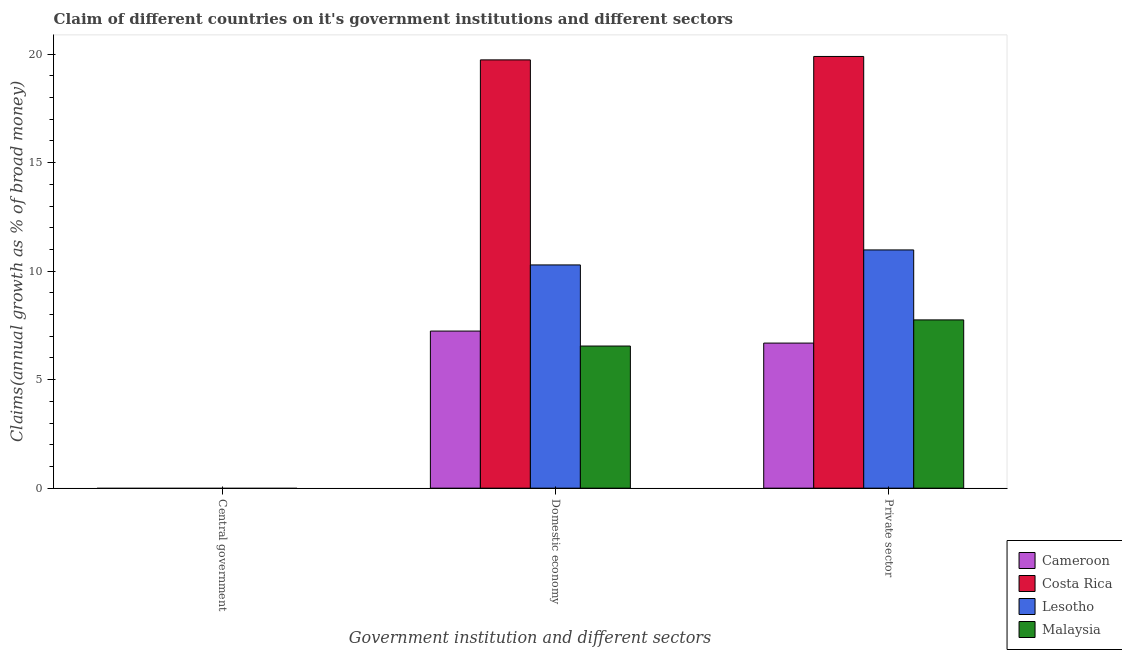Are the number of bars per tick equal to the number of legend labels?
Your response must be concise. No. Are the number of bars on each tick of the X-axis equal?
Offer a terse response. No. How many bars are there on the 3rd tick from the left?
Keep it short and to the point. 4. What is the label of the 2nd group of bars from the left?
Give a very brief answer. Domestic economy. What is the percentage of claim on the central government in Lesotho?
Offer a very short reply. 0. Across all countries, what is the maximum percentage of claim on the domestic economy?
Make the answer very short. 19.73. Across all countries, what is the minimum percentage of claim on the central government?
Ensure brevity in your answer.  0. What is the total percentage of claim on the domestic economy in the graph?
Your response must be concise. 43.81. What is the difference between the percentage of claim on the domestic economy in Lesotho and that in Costa Rica?
Your answer should be compact. -9.45. What is the difference between the percentage of claim on the central government in Cameroon and the percentage of claim on the private sector in Malaysia?
Offer a terse response. -7.75. What is the difference between the percentage of claim on the private sector and percentage of claim on the domestic economy in Cameroon?
Provide a short and direct response. -0.55. What is the ratio of the percentage of claim on the private sector in Costa Rica to that in Lesotho?
Provide a succinct answer. 1.81. What is the difference between the highest and the second highest percentage of claim on the private sector?
Provide a succinct answer. 8.91. What is the difference between the highest and the lowest percentage of claim on the private sector?
Provide a succinct answer. 13.21. In how many countries, is the percentage of claim on the domestic economy greater than the average percentage of claim on the domestic economy taken over all countries?
Keep it short and to the point. 1. Is it the case that in every country, the sum of the percentage of claim on the central government and percentage of claim on the domestic economy is greater than the percentage of claim on the private sector?
Provide a succinct answer. No. How many bars are there?
Your answer should be very brief. 8. What is the difference between two consecutive major ticks on the Y-axis?
Ensure brevity in your answer.  5. Where does the legend appear in the graph?
Offer a terse response. Bottom right. How are the legend labels stacked?
Make the answer very short. Vertical. What is the title of the graph?
Make the answer very short. Claim of different countries on it's government institutions and different sectors. Does "Sub-Saharan Africa (all income levels)" appear as one of the legend labels in the graph?
Provide a short and direct response. No. What is the label or title of the X-axis?
Provide a short and direct response. Government institution and different sectors. What is the label or title of the Y-axis?
Your response must be concise. Claims(annual growth as % of broad money). What is the Claims(annual growth as % of broad money) of Costa Rica in Central government?
Provide a short and direct response. 0. What is the Claims(annual growth as % of broad money) of Cameroon in Domestic economy?
Keep it short and to the point. 7.24. What is the Claims(annual growth as % of broad money) in Costa Rica in Domestic economy?
Offer a terse response. 19.73. What is the Claims(annual growth as % of broad money) of Lesotho in Domestic economy?
Provide a succinct answer. 10.29. What is the Claims(annual growth as % of broad money) in Malaysia in Domestic economy?
Ensure brevity in your answer.  6.55. What is the Claims(annual growth as % of broad money) of Cameroon in Private sector?
Offer a very short reply. 6.68. What is the Claims(annual growth as % of broad money) in Costa Rica in Private sector?
Your answer should be very brief. 19.89. What is the Claims(annual growth as % of broad money) in Lesotho in Private sector?
Offer a very short reply. 10.98. What is the Claims(annual growth as % of broad money) of Malaysia in Private sector?
Provide a short and direct response. 7.75. Across all Government institution and different sectors, what is the maximum Claims(annual growth as % of broad money) in Cameroon?
Your answer should be very brief. 7.24. Across all Government institution and different sectors, what is the maximum Claims(annual growth as % of broad money) of Costa Rica?
Ensure brevity in your answer.  19.89. Across all Government institution and different sectors, what is the maximum Claims(annual growth as % of broad money) of Lesotho?
Your answer should be very brief. 10.98. Across all Government institution and different sectors, what is the maximum Claims(annual growth as % of broad money) in Malaysia?
Your response must be concise. 7.75. Across all Government institution and different sectors, what is the minimum Claims(annual growth as % of broad money) of Lesotho?
Ensure brevity in your answer.  0. What is the total Claims(annual growth as % of broad money) of Cameroon in the graph?
Provide a short and direct response. 13.92. What is the total Claims(annual growth as % of broad money) of Costa Rica in the graph?
Make the answer very short. 39.62. What is the total Claims(annual growth as % of broad money) in Lesotho in the graph?
Ensure brevity in your answer.  21.26. What is the total Claims(annual growth as % of broad money) in Malaysia in the graph?
Offer a very short reply. 14.3. What is the difference between the Claims(annual growth as % of broad money) of Cameroon in Domestic economy and that in Private sector?
Offer a very short reply. 0.55. What is the difference between the Claims(annual growth as % of broad money) of Costa Rica in Domestic economy and that in Private sector?
Ensure brevity in your answer.  -0.16. What is the difference between the Claims(annual growth as % of broad money) in Lesotho in Domestic economy and that in Private sector?
Provide a succinct answer. -0.69. What is the difference between the Claims(annual growth as % of broad money) in Malaysia in Domestic economy and that in Private sector?
Your answer should be compact. -1.2. What is the difference between the Claims(annual growth as % of broad money) in Cameroon in Domestic economy and the Claims(annual growth as % of broad money) in Costa Rica in Private sector?
Ensure brevity in your answer.  -12.65. What is the difference between the Claims(annual growth as % of broad money) of Cameroon in Domestic economy and the Claims(annual growth as % of broad money) of Lesotho in Private sector?
Offer a very short reply. -3.74. What is the difference between the Claims(annual growth as % of broad money) in Cameroon in Domestic economy and the Claims(annual growth as % of broad money) in Malaysia in Private sector?
Make the answer very short. -0.51. What is the difference between the Claims(annual growth as % of broad money) of Costa Rica in Domestic economy and the Claims(annual growth as % of broad money) of Lesotho in Private sector?
Your response must be concise. 8.76. What is the difference between the Claims(annual growth as % of broad money) in Costa Rica in Domestic economy and the Claims(annual growth as % of broad money) in Malaysia in Private sector?
Your answer should be compact. 11.98. What is the difference between the Claims(annual growth as % of broad money) of Lesotho in Domestic economy and the Claims(annual growth as % of broad money) of Malaysia in Private sector?
Your answer should be compact. 2.53. What is the average Claims(annual growth as % of broad money) in Cameroon per Government institution and different sectors?
Offer a very short reply. 4.64. What is the average Claims(annual growth as % of broad money) of Costa Rica per Government institution and different sectors?
Offer a very short reply. 13.21. What is the average Claims(annual growth as % of broad money) in Lesotho per Government institution and different sectors?
Make the answer very short. 7.09. What is the average Claims(annual growth as % of broad money) of Malaysia per Government institution and different sectors?
Ensure brevity in your answer.  4.77. What is the difference between the Claims(annual growth as % of broad money) of Cameroon and Claims(annual growth as % of broad money) of Costa Rica in Domestic economy?
Provide a short and direct response. -12.5. What is the difference between the Claims(annual growth as % of broad money) of Cameroon and Claims(annual growth as % of broad money) of Lesotho in Domestic economy?
Keep it short and to the point. -3.05. What is the difference between the Claims(annual growth as % of broad money) in Cameroon and Claims(annual growth as % of broad money) in Malaysia in Domestic economy?
Provide a short and direct response. 0.69. What is the difference between the Claims(annual growth as % of broad money) in Costa Rica and Claims(annual growth as % of broad money) in Lesotho in Domestic economy?
Your answer should be very brief. 9.45. What is the difference between the Claims(annual growth as % of broad money) of Costa Rica and Claims(annual growth as % of broad money) of Malaysia in Domestic economy?
Offer a very short reply. 13.19. What is the difference between the Claims(annual growth as % of broad money) of Lesotho and Claims(annual growth as % of broad money) of Malaysia in Domestic economy?
Offer a terse response. 3.74. What is the difference between the Claims(annual growth as % of broad money) in Cameroon and Claims(annual growth as % of broad money) in Costa Rica in Private sector?
Your answer should be very brief. -13.21. What is the difference between the Claims(annual growth as % of broad money) in Cameroon and Claims(annual growth as % of broad money) in Lesotho in Private sector?
Provide a short and direct response. -4.29. What is the difference between the Claims(annual growth as % of broad money) in Cameroon and Claims(annual growth as % of broad money) in Malaysia in Private sector?
Keep it short and to the point. -1.07. What is the difference between the Claims(annual growth as % of broad money) of Costa Rica and Claims(annual growth as % of broad money) of Lesotho in Private sector?
Provide a short and direct response. 8.91. What is the difference between the Claims(annual growth as % of broad money) in Costa Rica and Claims(annual growth as % of broad money) in Malaysia in Private sector?
Offer a very short reply. 12.14. What is the difference between the Claims(annual growth as % of broad money) of Lesotho and Claims(annual growth as % of broad money) of Malaysia in Private sector?
Offer a very short reply. 3.22. What is the ratio of the Claims(annual growth as % of broad money) of Cameroon in Domestic economy to that in Private sector?
Ensure brevity in your answer.  1.08. What is the ratio of the Claims(annual growth as % of broad money) of Costa Rica in Domestic economy to that in Private sector?
Offer a terse response. 0.99. What is the ratio of the Claims(annual growth as % of broad money) in Lesotho in Domestic economy to that in Private sector?
Make the answer very short. 0.94. What is the ratio of the Claims(annual growth as % of broad money) in Malaysia in Domestic economy to that in Private sector?
Offer a very short reply. 0.84. What is the difference between the highest and the lowest Claims(annual growth as % of broad money) in Cameroon?
Give a very brief answer. 7.24. What is the difference between the highest and the lowest Claims(annual growth as % of broad money) of Costa Rica?
Make the answer very short. 19.89. What is the difference between the highest and the lowest Claims(annual growth as % of broad money) of Lesotho?
Give a very brief answer. 10.98. What is the difference between the highest and the lowest Claims(annual growth as % of broad money) in Malaysia?
Provide a succinct answer. 7.75. 